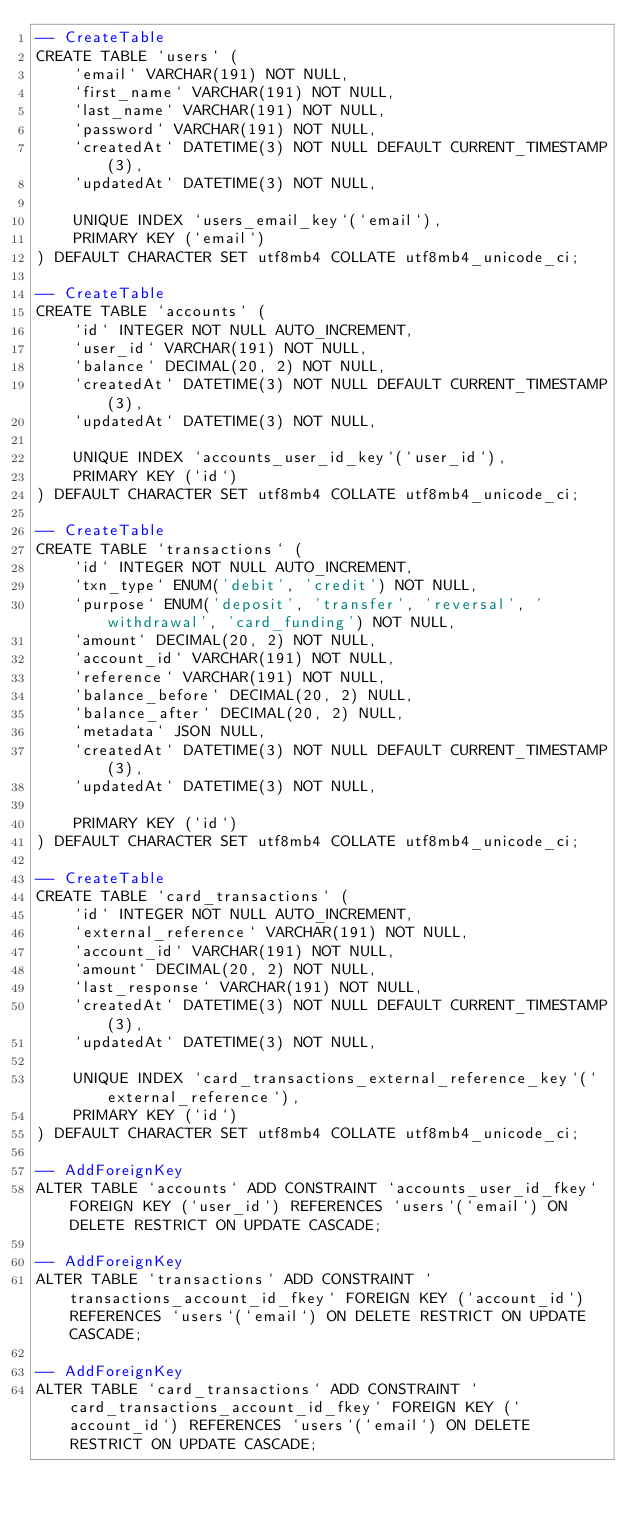Convert code to text. <code><loc_0><loc_0><loc_500><loc_500><_SQL_>-- CreateTable
CREATE TABLE `users` (
    `email` VARCHAR(191) NOT NULL,
    `first_name` VARCHAR(191) NOT NULL,
    `last_name` VARCHAR(191) NOT NULL,
    `password` VARCHAR(191) NOT NULL,
    `createdAt` DATETIME(3) NOT NULL DEFAULT CURRENT_TIMESTAMP(3),
    `updatedAt` DATETIME(3) NOT NULL,

    UNIQUE INDEX `users_email_key`(`email`),
    PRIMARY KEY (`email`)
) DEFAULT CHARACTER SET utf8mb4 COLLATE utf8mb4_unicode_ci;

-- CreateTable
CREATE TABLE `accounts` (
    `id` INTEGER NOT NULL AUTO_INCREMENT,
    `user_id` VARCHAR(191) NOT NULL,
    `balance` DECIMAL(20, 2) NOT NULL,
    `createdAt` DATETIME(3) NOT NULL DEFAULT CURRENT_TIMESTAMP(3),
    `updatedAt` DATETIME(3) NOT NULL,

    UNIQUE INDEX `accounts_user_id_key`(`user_id`),
    PRIMARY KEY (`id`)
) DEFAULT CHARACTER SET utf8mb4 COLLATE utf8mb4_unicode_ci;

-- CreateTable
CREATE TABLE `transactions` (
    `id` INTEGER NOT NULL AUTO_INCREMENT,
    `txn_type` ENUM('debit', 'credit') NOT NULL,
    `purpose` ENUM('deposit', 'transfer', 'reversal', 'withdrawal', 'card_funding') NOT NULL,
    `amount` DECIMAL(20, 2) NOT NULL,
    `account_id` VARCHAR(191) NOT NULL,
    `reference` VARCHAR(191) NOT NULL,
    `balance_before` DECIMAL(20, 2) NULL,
    `balance_after` DECIMAL(20, 2) NULL,
    `metadata` JSON NULL,
    `createdAt` DATETIME(3) NOT NULL DEFAULT CURRENT_TIMESTAMP(3),
    `updatedAt` DATETIME(3) NOT NULL,

    PRIMARY KEY (`id`)
) DEFAULT CHARACTER SET utf8mb4 COLLATE utf8mb4_unicode_ci;

-- CreateTable
CREATE TABLE `card_transactions` (
    `id` INTEGER NOT NULL AUTO_INCREMENT,
    `external_reference` VARCHAR(191) NOT NULL,
    `account_id` VARCHAR(191) NOT NULL,
    `amount` DECIMAL(20, 2) NOT NULL,
    `last_response` VARCHAR(191) NOT NULL,
    `createdAt` DATETIME(3) NOT NULL DEFAULT CURRENT_TIMESTAMP(3),
    `updatedAt` DATETIME(3) NOT NULL,

    UNIQUE INDEX `card_transactions_external_reference_key`(`external_reference`),
    PRIMARY KEY (`id`)
) DEFAULT CHARACTER SET utf8mb4 COLLATE utf8mb4_unicode_ci;

-- AddForeignKey
ALTER TABLE `accounts` ADD CONSTRAINT `accounts_user_id_fkey` FOREIGN KEY (`user_id`) REFERENCES `users`(`email`) ON DELETE RESTRICT ON UPDATE CASCADE;

-- AddForeignKey
ALTER TABLE `transactions` ADD CONSTRAINT `transactions_account_id_fkey` FOREIGN KEY (`account_id`) REFERENCES `users`(`email`) ON DELETE RESTRICT ON UPDATE CASCADE;

-- AddForeignKey
ALTER TABLE `card_transactions` ADD CONSTRAINT `card_transactions_account_id_fkey` FOREIGN KEY (`account_id`) REFERENCES `users`(`email`) ON DELETE RESTRICT ON UPDATE CASCADE;
</code> 